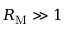<formula> <loc_0><loc_0><loc_500><loc_500>R _ { M } \gg 1</formula> 